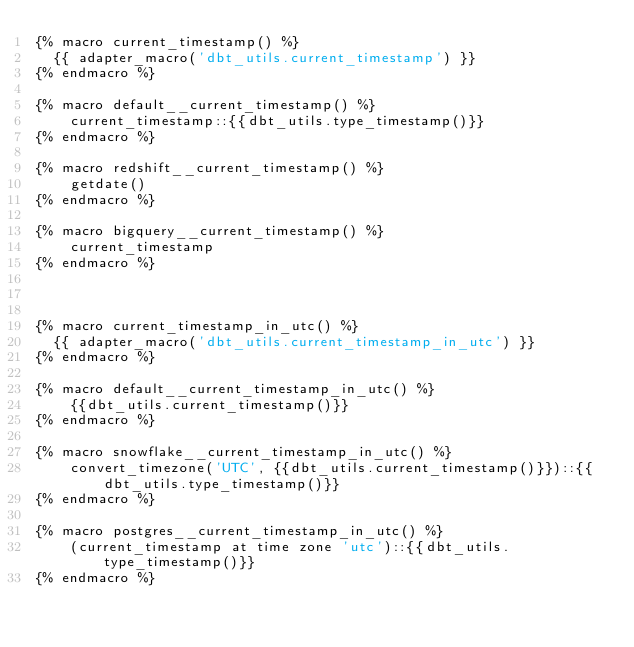<code> <loc_0><loc_0><loc_500><loc_500><_SQL_>{% macro current_timestamp() %}
  {{ adapter_macro('dbt_utils.current_timestamp') }}
{% endmacro %}

{% macro default__current_timestamp() %}
    current_timestamp::{{dbt_utils.type_timestamp()}}
{% endmacro %}

{% macro redshift__current_timestamp() %}
    getdate()
{% endmacro %}

{% macro bigquery__current_timestamp() %}
    current_timestamp
{% endmacro %}



{% macro current_timestamp_in_utc() %}
  {{ adapter_macro('dbt_utils.current_timestamp_in_utc') }}
{% endmacro %}

{% macro default__current_timestamp_in_utc() %}
    {{dbt_utils.current_timestamp()}}
{% endmacro %}

{% macro snowflake__current_timestamp_in_utc() %}
    convert_timezone('UTC', {{dbt_utils.current_timestamp()}})::{{dbt_utils.type_timestamp()}}
{% endmacro %}

{% macro postgres__current_timestamp_in_utc() %}
    (current_timestamp at time zone 'utc')::{{dbt_utils.type_timestamp()}}
{% endmacro %}
</code> 